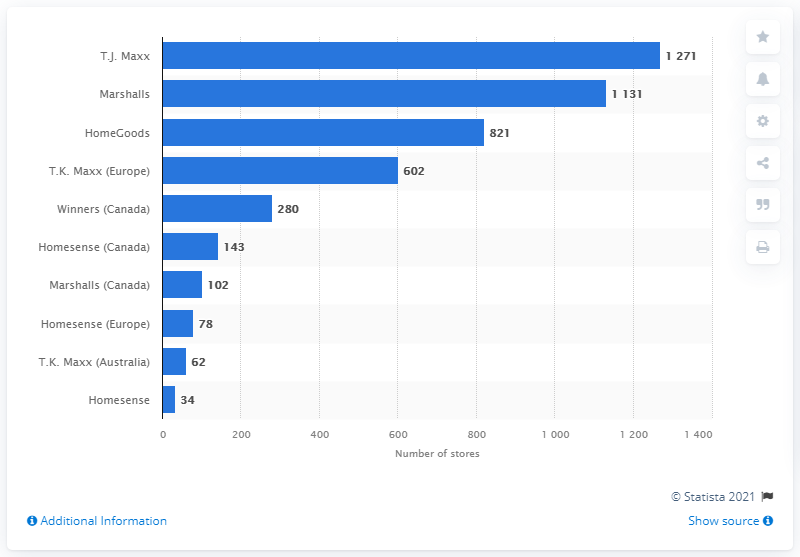Give some essential details in this illustration. HomeGoods and Homesense are both retailers that are known for offering a wide range of high-quality home goods at affordable prices. HomeGoods, in particular, is known for its vast selection of home decor and accessories, while Homesense is known for its focus on home decor and home furnishings. Marshalls has 102 stores in Canada. 